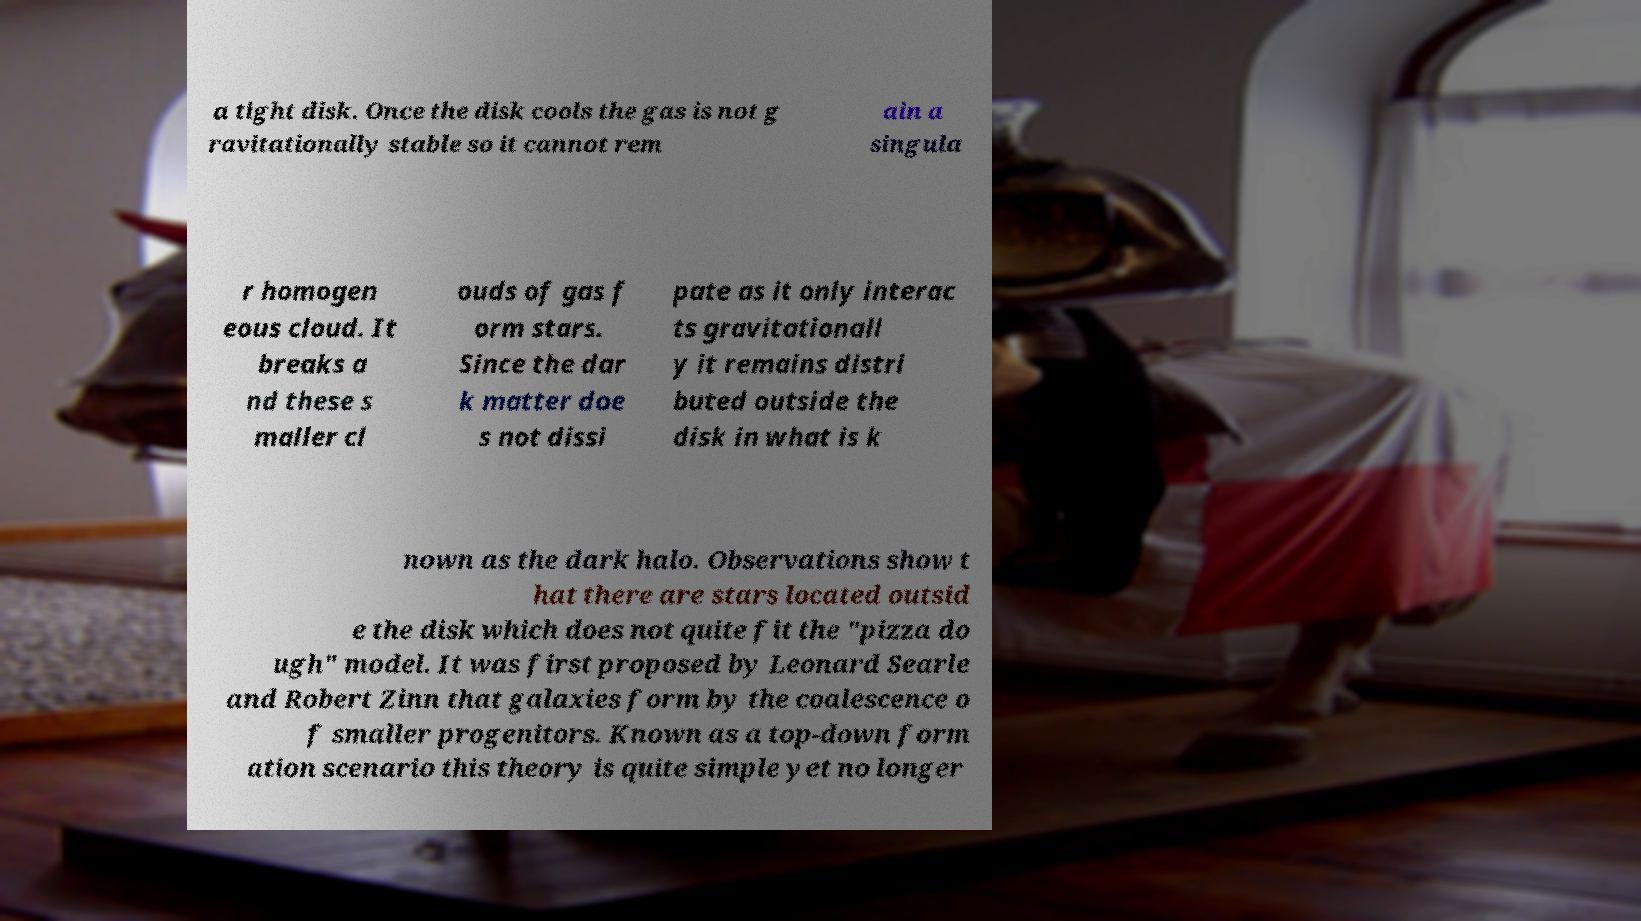Please read and relay the text visible in this image. What does it say? a tight disk. Once the disk cools the gas is not g ravitationally stable so it cannot rem ain a singula r homogen eous cloud. It breaks a nd these s maller cl ouds of gas f orm stars. Since the dar k matter doe s not dissi pate as it only interac ts gravitationall y it remains distri buted outside the disk in what is k nown as the dark halo. Observations show t hat there are stars located outsid e the disk which does not quite fit the "pizza do ugh" model. It was first proposed by Leonard Searle and Robert Zinn that galaxies form by the coalescence o f smaller progenitors. Known as a top-down form ation scenario this theory is quite simple yet no longer 